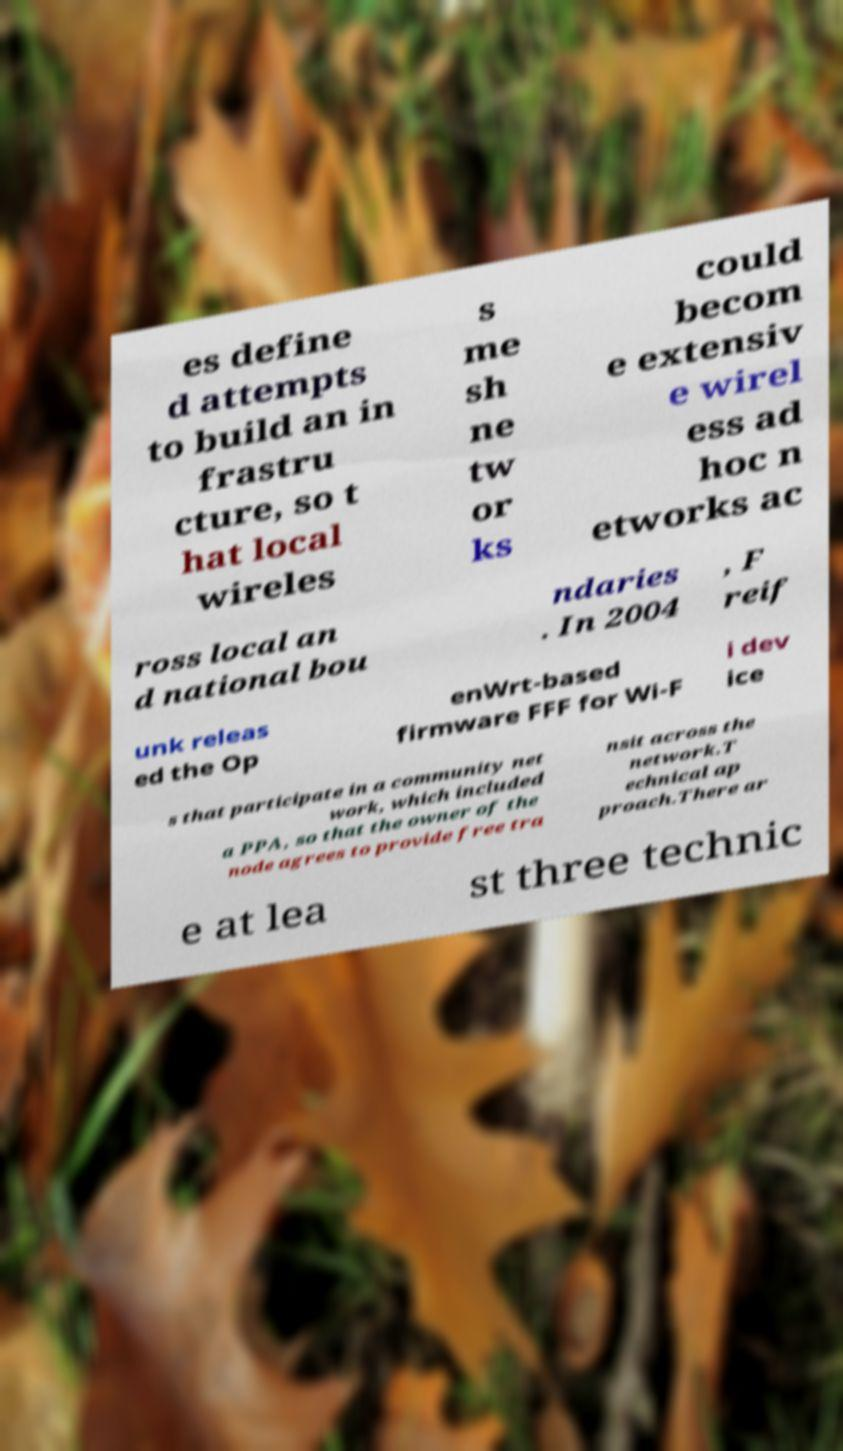Can you accurately transcribe the text from the provided image for me? es define d attempts to build an in frastru cture, so t hat local wireles s me sh ne tw or ks could becom e extensiv e wirel ess ad hoc n etworks ac ross local an d national bou ndaries . In 2004 , F reif unk releas ed the Op enWrt-based firmware FFF for Wi-F i dev ice s that participate in a community net work, which included a PPA, so that the owner of the node agrees to provide free tra nsit across the network.T echnical ap proach.There ar e at lea st three technic 